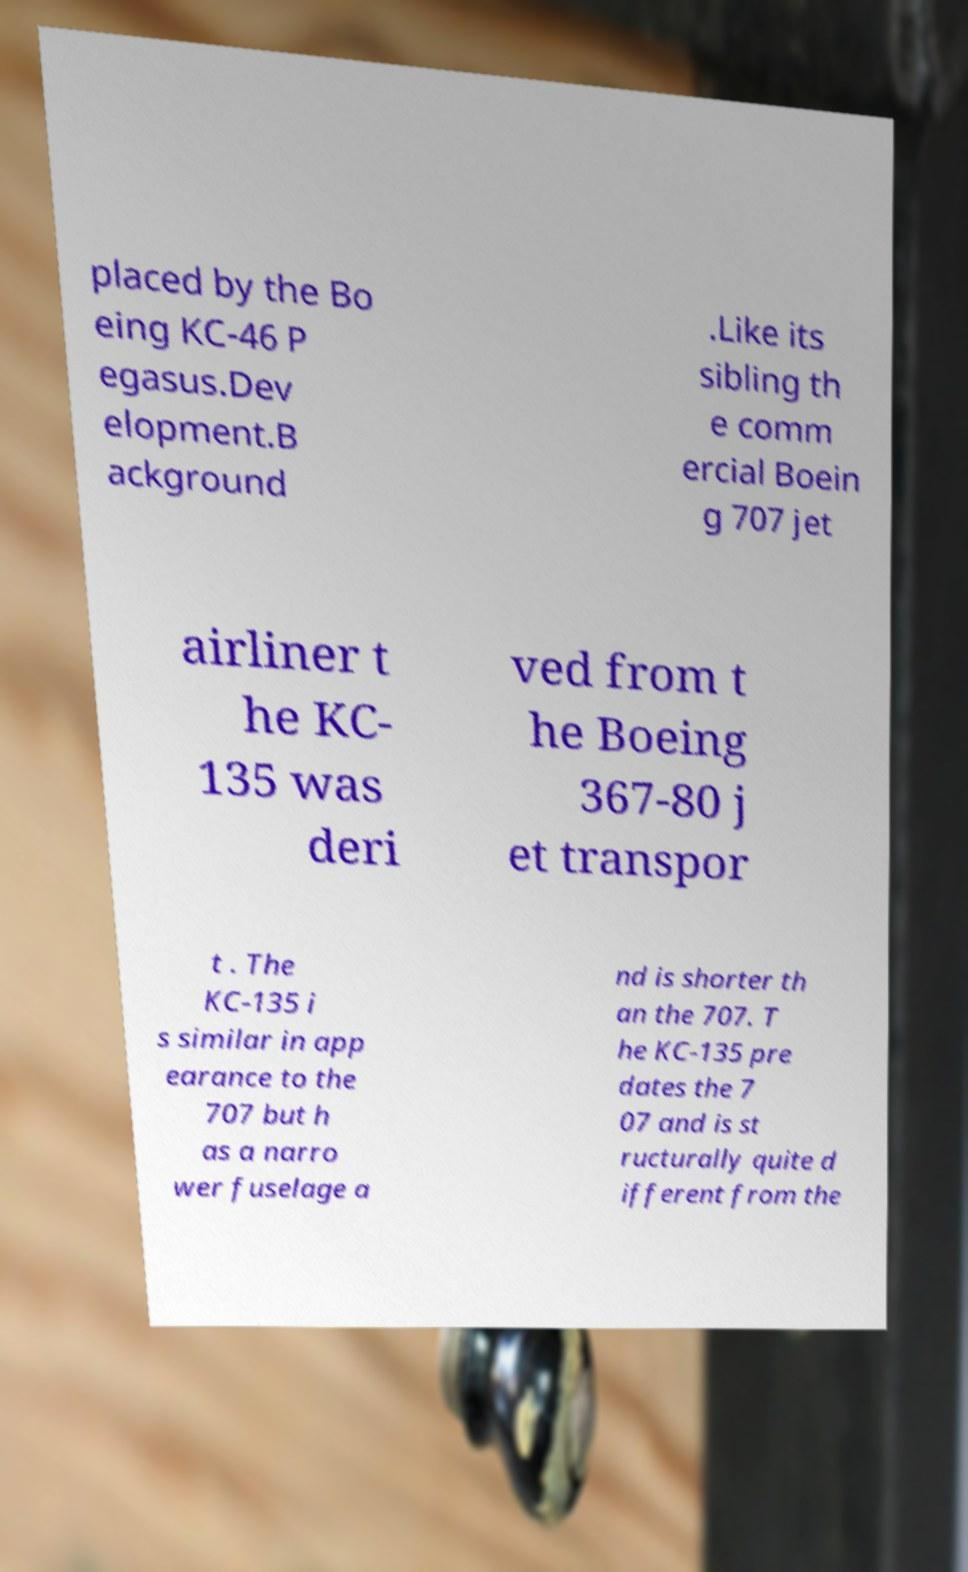I need the written content from this picture converted into text. Can you do that? placed by the Bo eing KC-46 P egasus.Dev elopment.B ackground .Like its sibling th e comm ercial Boein g 707 jet airliner t he KC- 135 was deri ved from t he Boeing 367-80 j et transpor t . The KC-135 i s similar in app earance to the 707 but h as a narro wer fuselage a nd is shorter th an the 707. T he KC-135 pre dates the 7 07 and is st ructurally quite d ifferent from the 